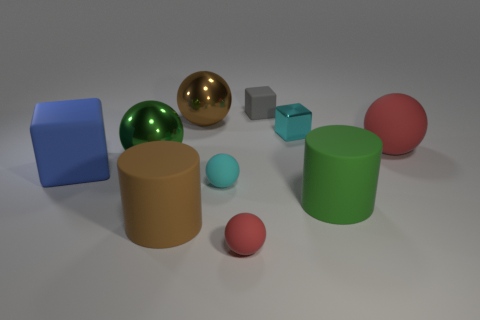Is the color of the matte cube that is on the right side of the large brown shiny ball the same as the small sphere to the left of the tiny red ball?
Provide a short and direct response. No. Are there any large purple shiny cylinders?
Your answer should be very brief. No. Is there a large cylinder that has the same material as the brown ball?
Keep it short and to the point. No. Is there anything else that has the same material as the small gray block?
Your answer should be compact. Yes. The metallic block has what color?
Offer a terse response. Cyan. There is another small thing that is the same color as the tiny metal object; what shape is it?
Your response must be concise. Sphere. There is a matte cylinder that is the same size as the brown matte thing; what color is it?
Give a very brief answer. Green. How many metal things are large balls or large green things?
Ensure brevity in your answer.  2. What number of matte objects are right of the tiny cyan block and left of the tiny gray cube?
Provide a succinct answer. 0. How many other objects are there of the same size as the cyan metal thing?
Your answer should be compact. 3. 